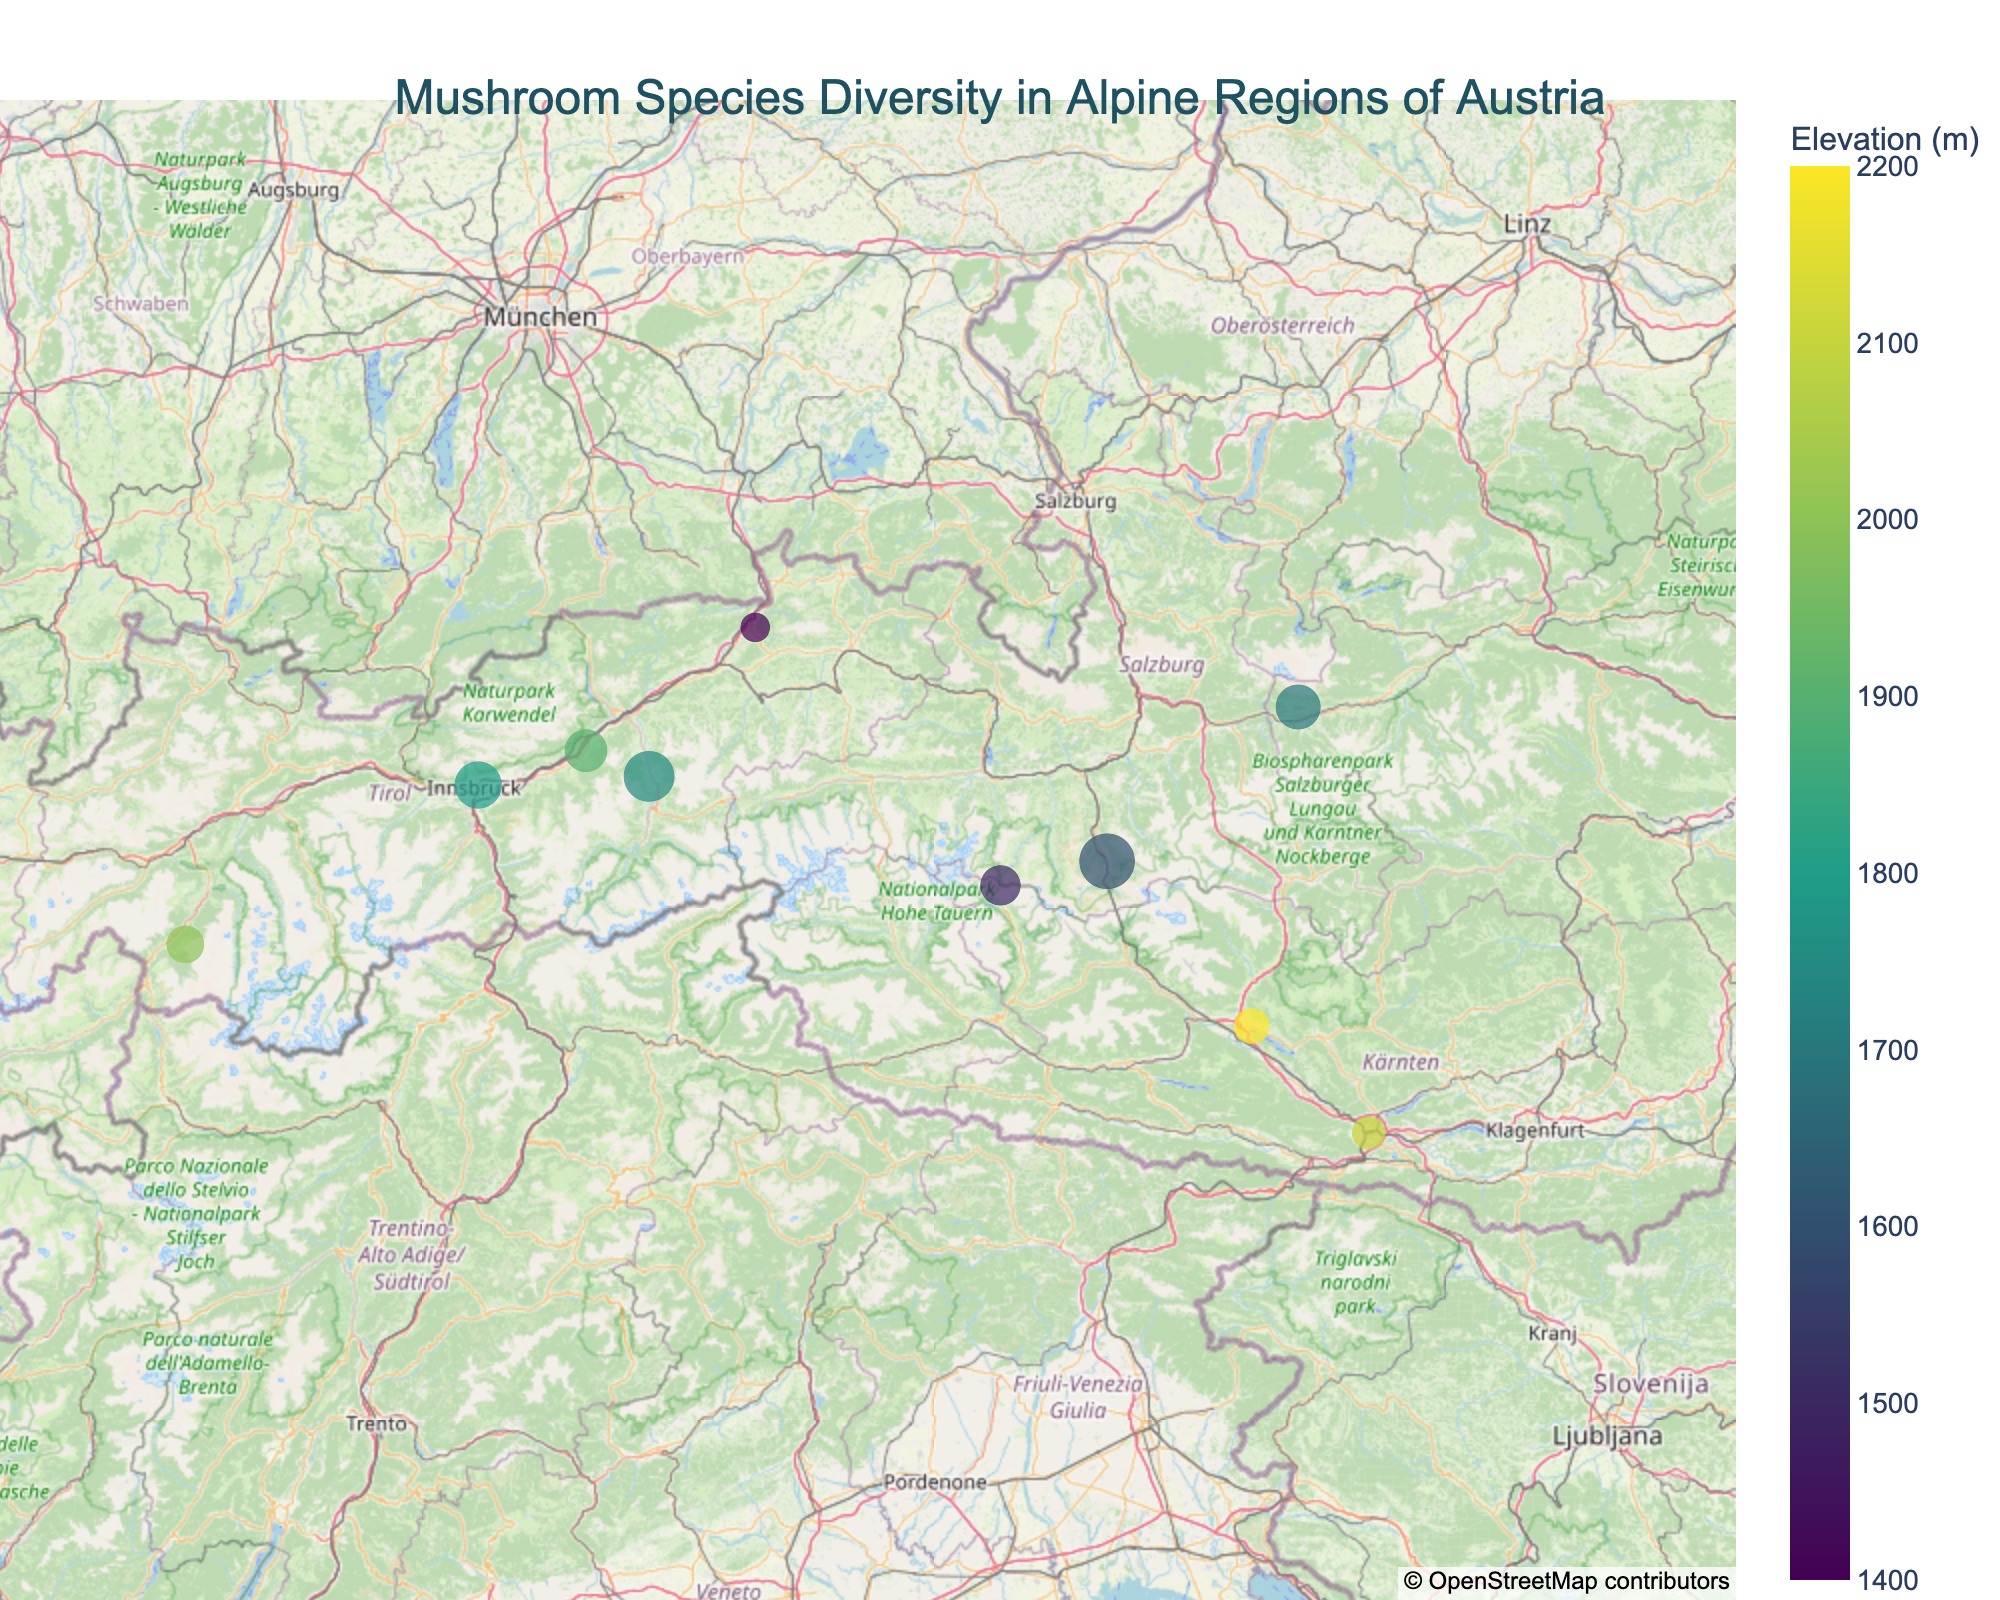How many different mushroom species are shown on the map? To find the number of different mushroom species, examine the legend or count the unique species names listed in the hover information on the map.
Answer: 10 Which mushroom species is found at the highest elevation? Check the hover information for each mushroom species and look for the one with the highest elevation value.
Answer: Russula cyanoxantha What is the elevation range of the plotted mushroom species? Identify the minimum and maximum elevation values from the hover information and subtract the minimum from the maximum elevation value. The elevations range from 1400 m to 2200 m, so 2200 m - 1400 m = 800 m.
Answer: 800 m Which researcher recorded the most abundant mushroom species? Look for the largest circle on the map, indicating the highest abundance. By examining the hover information of this circle, identify the researcher associated with it.
Answer: Birgit Pichler Are there any mushroom species with the same name recorded by different researchers? Compare the species names listed in the hover information for different positions on the map. If you find any repetition of species names, then those species were recorded by different researchers.
Answer: No Which area (latitude and longitude) has the highest mushroom abundance? Locate the largest circle on the map (indicating the highest abundance) and check its latitude and longitude from the hover information.
Answer: (47.2854, 11.8735) Is there a correlation between elevation and mushroom species abundance? Visually inspect the map to see if there is a trend in circle sizes (representing abundance) with elevation. For instance, check if the larger circles (higher abundances) are consistently found at higher or lower elevations.
Answer: None (based on visual inspection, there's no clear correlation) Which mushroom species is found closest to the center of the map? Take note of the map's center coordinates and compare the latitude and longitude of each mushroom species (from the hover information) to find the closest one.
Answer: Boletus edulis Which mushroom species is recorded by the researcher Anna Steiner and at what location? Search the hover information for the researcher name "Anna Steiner" and note down the species name and its latitudinal and longitudinal coordinates.
Answer: Lactarius deliciosus, (47.3333, 11.7000) How does the abundance of Macrolepiota procera compare to other species? Check the hover information for Macrolepiota procera and note its abundance, then compare this number to the abundances of other species on the map.
Answer: Mid-range (33, compared to others) 